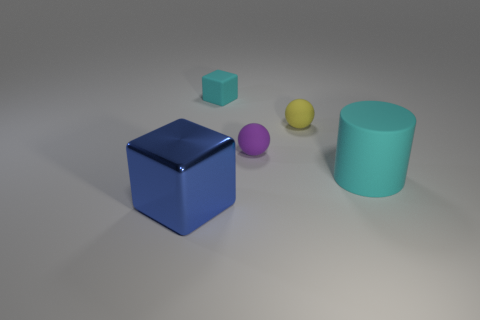Add 1 large green metallic objects. How many objects exist? 6 Subtract all spheres. How many objects are left? 3 Subtract all cyan blocks. How many blocks are left? 1 Subtract 1 cylinders. How many cylinders are left? 0 Subtract all yellow blocks. Subtract all gray cylinders. How many blocks are left? 2 Subtract all gray cylinders. How many brown cubes are left? 0 Subtract all yellow rubber balls. Subtract all purple rubber objects. How many objects are left? 3 Add 1 large metallic cubes. How many large metallic cubes are left? 2 Add 3 things. How many things exist? 8 Subtract 1 cyan cubes. How many objects are left? 4 